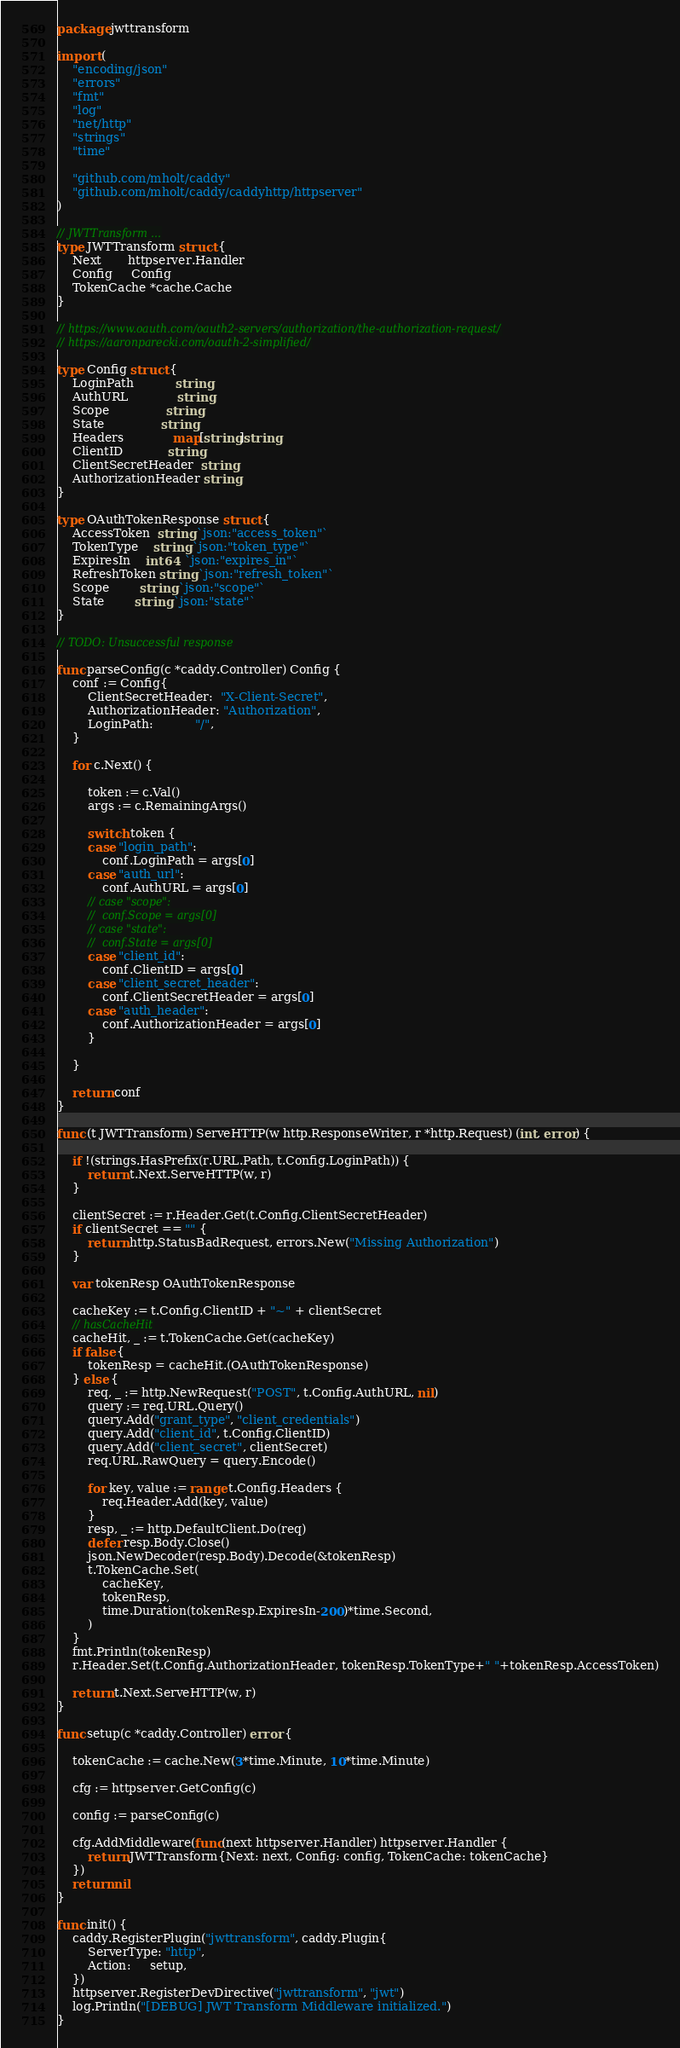Convert code to text. <code><loc_0><loc_0><loc_500><loc_500><_Go_>package jwttransform

import (
	"encoding/json"
	"errors"
	"fmt"
	"log"
	"net/http"
	"strings"
	"time"

	"github.com/mholt/caddy"
	"github.com/mholt/caddy/caddyhttp/httpserver"
)

// JWTTransform ...
type JWTTransform struct {
	Next       httpserver.Handler
	Config     Config
	TokenCache *cache.Cache
}

// https://www.oauth.com/oauth2-servers/authorization/the-authorization-request/
// https://aaronparecki.com/oauth-2-simplified/

type Config struct {
	LoginPath           string
	AuthURL             string
	Scope               string
	State               string
	Headers             map[string]string
	ClientID            string
	ClientSecretHeader  string
	AuthorizationHeader string
}

type OAuthTokenResponse struct {
	AccessToken  string `json:"access_token"`
	TokenType    string `json:"token_type"`
	ExpiresIn    int64  `json:"expires_in"`
	RefreshToken string `json:"refresh_token"`
	Scope        string `json:"scope"`
	State        string `json:"state"`
}

// TODO: Unsuccessful response

func parseConfig(c *caddy.Controller) Config {
	conf := Config{
		ClientSecretHeader:  "X-Client-Secret",
		AuthorizationHeader: "Authorization",
		LoginPath:           "/",
	}

	for c.Next() {

		token := c.Val()
		args := c.RemainingArgs()

		switch token {
		case "login_path":
			conf.LoginPath = args[0]
		case "auth_url":
			conf.AuthURL = args[0]
		// case "scope":
		// 	conf.Scope = args[0]
		// case "state":
		// 	conf.State = args[0]
		case "client_id":
			conf.ClientID = args[0]
		case "client_secret_header":
			conf.ClientSecretHeader = args[0]
		case "auth_header":
			conf.AuthorizationHeader = args[0]
		}

	}

	return conf
}

func (t JWTTransform) ServeHTTP(w http.ResponseWriter, r *http.Request) (int, error) {

	if !(strings.HasPrefix(r.URL.Path, t.Config.LoginPath)) {
		return t.Next.ServeHTTP(w, r)
	}

	clientSecret := r.Header.Get(t.Config.ClientSecretHeader)
	if clientSecret == "" {
		return http.StatusBadRequest, errors.New("Missing Authorization")
	}

	var tokenResp OAuthTokenResponse

	cacheKey := t.Config.ClientID + "~" + clientSecret
	// hasCacheHit
	cacheHit, _ := t.TokenCache.Get(cacheKey)
	if false {
		tokenResp = cacheHit.(OAuthTokenResponse)
	} else {
		req, _ := http.NewRequest("POST", t.Config.AuthURL, nil)
		query := req.URL.Query()
		query.Add("grant_type", "client_credentials")
		query.Add("client_id", t.Config.ClientID)
		query.Add("client_secret", clientSecret)
		req.URL.RawQuery = query.Encode()

		for key, value := range t.Config.Headers {
			req.Header.Add(key, value)
		}
		resp, _ := http.DefaultClient.Do(req)
		defer resp.Body.Close()
		json.NewDecoder(resp.Body).Decode(&tokenResp)
		t.TokenCache.Set(
			cacheKey,
			tokenResp,
			time.Duration(tokenResp.ExpiresIn-200)*time.Second,
		)
	}
	fmt.Println(tokenResp)
	r.Header.Set(t.Config.AuthorizationHeader, tokenResp.TokenType+" "+tokenResp.AccessToken)

	return t.Next.ServeHTTP(w, r)
}

func setup(c *caddy.Controller) error {

	tokenCache := cache.New(3*time.Minute, 10*time.Minute)

	cfg := httpserver.GetConfig(c)

	config := parseConfig(c)

	cfg.AddMiddleware(func(next httpserver.Handler) httpserver.Handler {
		return JWTTransform{Next: next, Config: config, TokenCache: tokenCache}
	})
	return nil
}

func init() {
	caddy.RegisterPlugin("jwttransform", caddy.Plugin{
		ServerType: "http",
		Action:     setup,
	})
	httpserver.RegisterDevDirective("jwttransform", "jwt")
	log.Println("[DEBUG] JWT Transform Middleware initialized.")
}
</code> 